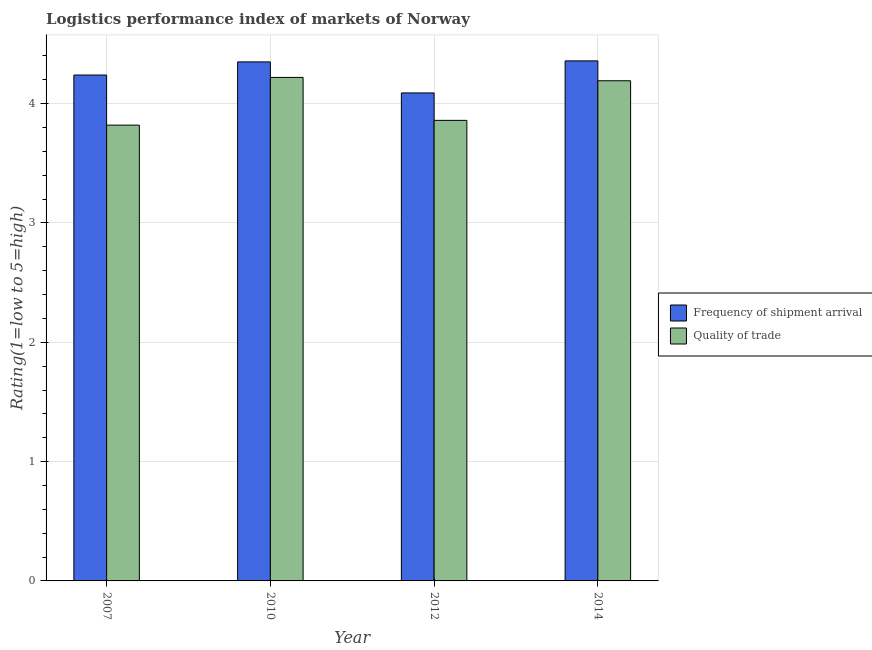How many different coloured bars are there?
Your response must be concise. 2. How many groups of bars are there?
Ensure brevity in your answer.  4. Are the number of bars on each tick of the X-axis equal?
Offer a terse response. Yes. How many bars are there on the 3rd tick from the left?
Ensure brevity in your answer.  2. What is the label of the 2nd group of bars from the left?
Offer a terse response. 2010. In how many cases, is the number of bars for a given year not equal to the number of legend labels?
Ensure brevity in your answer.  0. What is the lpi quality of trade in 2012?
Your answer should be compact. 3.86. Across all years, what is the maximum lpi of frequency of shipment arrival?
Ensure brevity in your answer.  4.36. Across all years, what is the minimum lpi of frequency of shipment arrival?
Offer a very short reply. 4.09. In which year was the lpi of frequency of shipment arrival maximum?
Provide a succinct answer. 2014. What is the total lpi of frequency of shipment arrival in the graph?
Provide a short and direct response. 17.04. What is the difference between the lpi of frequency of shipment arrival in 2010 and that in 2012?
Offer a terse response. 0.26. What is the difference between the lpi quality of trade in 2010 and the lpi of frequency of shipment arrival in 2007?
Give a very brief answer. 0.4. What is the average lpi of frequency of shipment arrival per year?
Make the answer very short. 4.26. In how many years, is the lpi quality of trade greater than 4?
Ensure brevity in your answer.  2. What is the ratio of the lpi of frequency of shipment arrival in 2012 to that in 2014?
Your response must be concise. 0.94. Is the lpi of frequency of shipment arrival in 2007 less than that in 2010?
Your answer should be compact. Yes. What is the difference between the highest and the second highest lpi quality of trade?
Offer a terse response. 0.03. What is the difference between the highest and the lowest lpi quality of trade?
Your answer should be compact. 0.4. In how many years, is the lpi quality of trade greater than the average lpi quality of trade taken over all years?
Keep it short and to the point. 2. Is the sum of the lpi of frequency of shipment arrival in 2007 and 2012 greater than the maximum lpi quality of trade across all years?
Provide a succinct answer. Yes. What does the 2nd bar from the left in 2007 represents?
Provide a succinct answer. Quality of trade. What does the 2nd bar from the right in 2012 represents?
Offer a terse response. Frequency of shipment arrival. What is the difference between two consecutive major ticks on the Y-axis?
Your answer should be compact. 1. How many legend labels are there?
Offer a terse response. 2. What is the title of the graph?
Ensure brevity in your answer.  Logistics performance index of markets of Norway. What is the label or title of the Y-axis?
Your answer should be very brief. Rating(1=low to 5=high). What is the Rating(1=low to 5=high) in Frequency of shipment arrival in 2007?
Provide a succinct answer. 4.24. What is the Rating(1=low to 5=high) in Quality of trade in 2007?
Your answer should be compact. 3.82. What is the Rating(1=low to 5=high) of Frequency of shipment arrival in 2010?
Your answer should be compact. 4.35. What is the Rating(1=low to 5=high) in Quality of trade in 2010?
Your answer should be very brief. 4.22. What is the Rating(1=low to 5=high) of Frequency of shipment arrival in 2012?
Keep it short and to the point. 4.09. What is the Rating(1=low to 5=high) of Quality of trade in 2012?
Your response must be concise. 3.86. What is the Rating(1=low to 5=high) in Frequency of shipment arrival in 2014?
Your response must be concise. 4.36. What is the Rating(1=low to 5=high) of Quality of trade in 2014?
Offer a very short reply. 4.19. Across all years, what is the maximum Rating(1=low to 5=high) of Frequency of shipment arrival?
Offer a terse response. 4.36. Across all years, what is the maximum Rating(1=low to 5=high) of Quality of trade?
Keep it short and to the point. 4.22. Across all years, what is the minimum Rating(1=low to 5=high) in Frequency of shipment arrival?
Make the answer very short. 4.09. Across all years, what is the minimum Rating(1=low to 5=high) in Quality of trade?
Keep it short and to the point. 3.82. What is the total Rating(1=low to 5=high) in Frequency of shipment arrival in the graph?
Make the answer very short. 17.04. What is the total Rating(1=low to 5=high) in Quality of trade in the graph?
Make the answer very short. 16.09. What is the difference between the Rating(1=low to 5=high) in Frequency of shipment arrival in 2007 and that in 2010?
Ensure brevity in your answer.  -0.11. What is the difference between the Rating(1=low to 5=high) in Quality of trade in 2007 and that in 2010?
Provide a short and direct response. -0.4. What is the difference between the Rating(1=low to 5=high) in Frequency of shipment arrival in 2007 and that in 2012?
Offer a very short reply. 0.15. What is the difference between the Rating(1=low to 5=high) in Quality of trade in 2007 and that in 2012?
Provide a succinct answer. -0.04. What is the difference between the Rating(1=low to 5=high) in Frequency of shipment arrival in 2007 and that in 2014?
Ensure brevity in your answer.  -0.12. What is the difference between the Rating(1=low to 5=high) in Quality of trade in 2007 and that in 2014?
Provide a short and direct response. -0.37. What is the difference between the Rating(1=low to 5=high) of Frequency of shipment arrival in 2010 and that in 2012?
Provide a succinct answer. 0.26. What is the difference between the Rating(1=low to 5=high) in Quality of trade in 2010 and that in 2012?
Your response must be concise. 0.36. What is the difference between the Rating(1=low to 5=high) in Frequency of shipment arrival in 2010 and that in 2014?
Keep it short and to the point. -0.01. What is the difference between the Rating(1=low to 5=high) in Quality of trade in 2010 and that in 2014?
Offer a terse response. 0.03. What is the difference between the Rating(1=low to 5=high) in Frequency of shipment arrival in 2012 and that in 2014?
Your answer should be compact. -0.27. What is the difference between the Rating(1=low to 5=high) of Quality of trade in 2012 and that in 2014?
Give a very brief answer. -0.33. What is the difference between the Rating(1=low to 5=high) of Frequency of shipment arrival in 2007 and the Rating(1=low to 5=high) of Quality of trade in 2010?
Offer a very short reply. 0.02. What is the difference between the Rating(1=low to 5=high) of Frequency of shipment arrival in 2007 and the Rating(1=low to 5=high) of Quality of trade in 2012?
Your answer should be compact. 0.38. What is the difference between the Rating(1=low to 5=high) in Frequency of shipment arrival in 2007 and the Rating(1=low to 5=high) in Quality of trade in 2014?
Give a very brief answer. 0.05. What is the difference between the Rating(1=low to 5=high) in Frequency of shipment arrival in 2010 and the Rating(1=low to 5=high) in Quality of trade in 2012?
Offer a terse response. 0.49. What is the difference between the Rating(1=low to 5=high) in Frequency of shipment arrival in 2010 and the Rating(1=low to 5=high) in Quality of trade in 2014?
Provide a succinct answer. 0.16. What is the difference between the Rating(1=low to 5=high) of Frequency of shipment arrival in 2012 and the Rating(1=low to 5=high) of Quality of trade in 2014?
Offer a very short reply. -0.1. What is the average Rating(1=low to 5=high) in Frequency of shipment arrival per year?
Your response must be concise. 4.26. What is the average Rating(1=low to 5=high) in Quality of trade per year?
Offer a very short reply. 4.02. In the year 2007, what is the difference between the Rating(1=low to 5=high) in Frequency of shipment arrival and Rating(1=low to 5=high) in Quality of trade?
Your response must be concise. 0.42. In the year 2010, what is the difference between the Rating(1=low to 5=high) of Frequency of shipment arrival and Rating(1=low to 5=high) of Quality of trade?
Provide a short and direct response. 0.13. In the year 2012, what is the difference between the Rating(1=low to 5=high) of Frequency of shipment arrival and Rating(1=low to 5=high) of Quality of trade?
Ensure brevity in your answer.  0.23. In the year 2014, what is the difference between the Rating(1=low to 5=high) in Frequency of shipment arrival and Rating(1=low to 5=high) in Quality of trade?
Provide a succinct answer. 0.17. What is the ratio of the Rating(1=low to 5=high) in Frequency of shipment arrival in 2007 to that in 2010?
Provide a short and direct response. 0.97. What is the ratio of the Rating(1=low to 5=high) of Quality of trade in 2007 to that in 2010?
Keep it short and to the point. 0.91. What is the ratio of the Rating(1=low to 5=high) of Frequency of shipment arrival in 2007 to that in 2012?
Your answer should be compact. 1.04. What is the ratio of the Rating(1=low to 5=high) of Quality of trade in 2007 to that in 2012?
Your response must be concise. 0.99. What is the ratio of the Rating(1=low to 5=high) in Frequency of shipment arrival in 2007 to that in 2014?
Your answer should be very brief. 0.97. What is the ratio of the Rating(1=low to 5=high) in Quality of trade in 2007 to that in 2014?
Make the answer very short. 0.91. What is the ratio of the Rating(1=low to 5=high) of Frequency of shipment arrival in 2010 to that in 2012?
Offer a very short reply. 1.06. What is the ratio of the Rating(1=low to 5=high) of Quality of trade in 2010 to that in 2012?
Provide a short and direct response. 1.09. What is the ratio of the Rating(1=low to 5=high) in Frequency of shipment arrival in 2010 to that in 2014?
Provide a succinct answer. 1. What is the ratio of the Rating(1=low to 5=high) of Frequency of shipment arrival in 2012 to that in 2014?
Offer a very short reply. 0.94. What is the ratio of the Rating(1=low to 5=high) of Quality of trade in 2012 to that in 2014?
Make the answer very short. 0.92. What is the difference between the highest and the second highest Rating(1=low to 5=high) of Frequency of shipment arrival?
Provide a short and direct response. 0.01. What is the difference between the highest and the second highest Rating(1=low to 5=high) of Quality of trade?
Your response must be concise. 0.03. What is the difference between the highest and the lowest Rating(1=low to 5=high) of Frequency of shipment arrival?
Ensure brevity in your answer.  0.27. What is the difference between the highest and the lowest Rating(1=low to 5=high) in Quality of trade?
Provide a succinct answer. 0.4. 